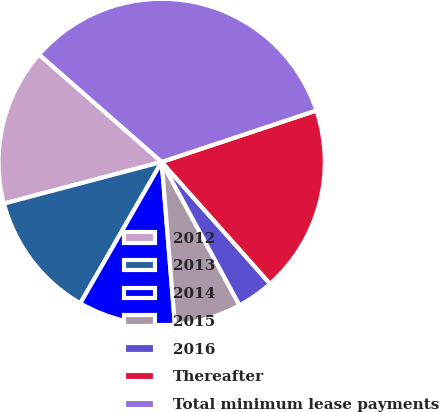<chart> <loc_0><loc_0><loc_500><loc_500><pie_chart><fcel>2012<fcel>2013<fcel>2014<fcel>2015<fcel>2016<fcel>Thereafter<fcel>Total minimum lease payments<nl><fcel>15.56%<fcel>12.58%<fcel>9.6%<fcel>6.63%<fcel>3.65%<fcel>18.54%<fcel>33.43%<nl></chart> 